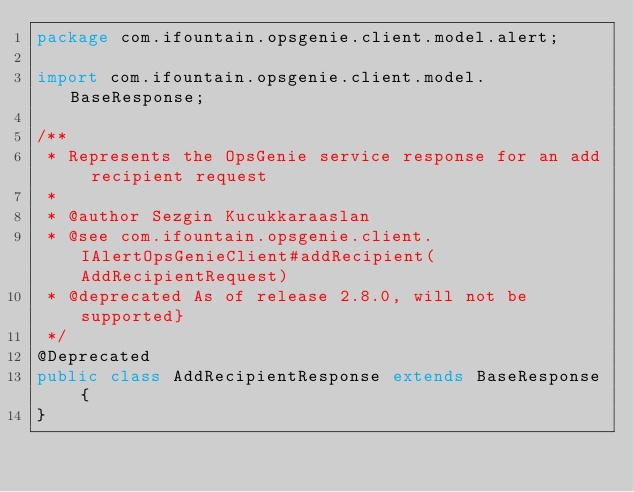Convert code to text. <code><loc_0><loc_0><loc_500><loc_500><_Java_>package com.ifountain.opsgenie.client.model.alert;

import com.ifountain.opsgenie.client.model.BaseResponse;

/**
 * Represents the OpsGenie service response for an add recipient request
 *
 * @author Sezgin Kucukkaraaslan
 * @see com.ifountain.opsgenie.client.IAlertOpsGenieClient#addRecipient(AddRecipientRequest)
 * @deprecated As of release 2.8.0, will not be supported}
 */
@Deprecated
public class AddRecipientResponse extends BaseResponse {
}
</code> 